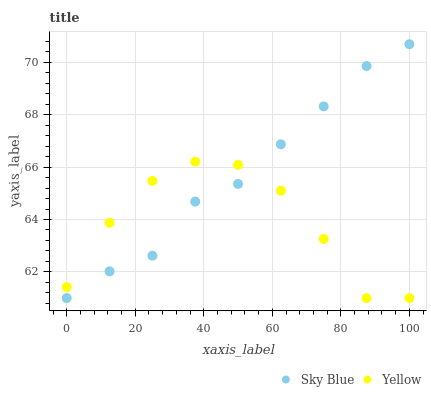Does Yellow have the minimum area under the curve?
Answer yes or no. Yes. Does Sky Blue have the maximum area under the curve?
Answer yes or no. Yes. Does Yellow have the maximum area under the curve?
Answer yes or no. No. Is Sky Blue the smoothest?
Answer yes or no. Yes. Is Yellow the roughest?
Answer yes or no. Yes. Is Yellow the smoothest?
Answer yes or no. No. Does Sky Blue have the lowest value?
Answer yes or no. Yes. Does Sky Blue have the highest value?
Answer yes or no. Yes. Does Yellow have the highest value?
Answer yes or no. No. Does Yellow intersect Sky Blue?
Answer yes or no. Yes. Is Yellow less than Sky Blue?
Answer yes or no. No. Is Yellow greater than Sky Blue?
Answer yes or no. No. 